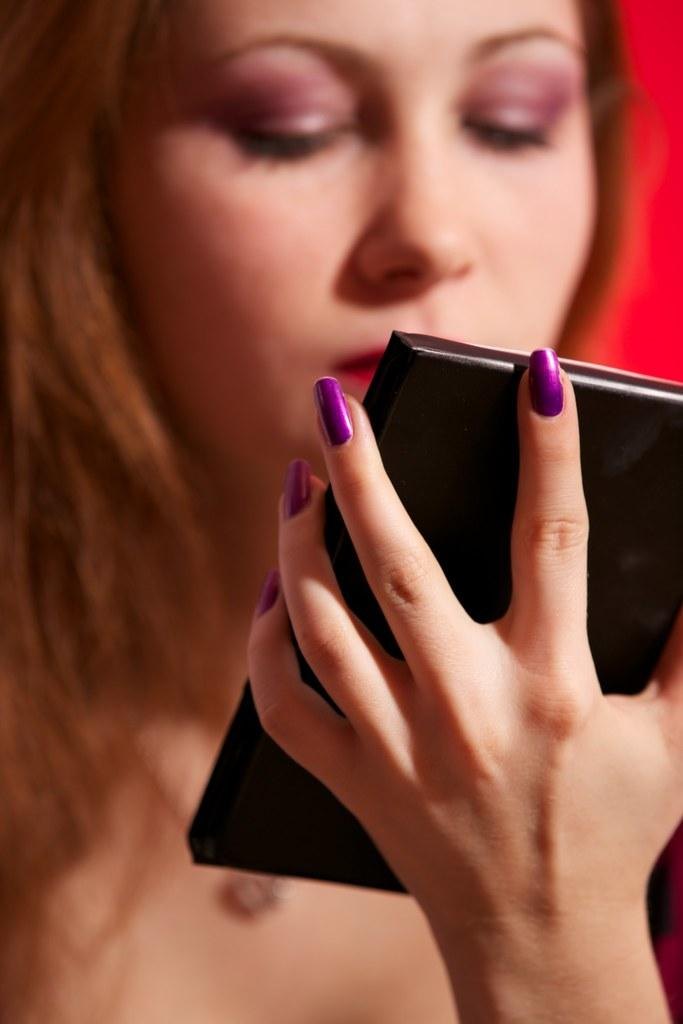Who is the main subject in the image? There is a woman in the image. What is the woman doing with her hand? The woman is holding an object with her hand. Can you describe the background of the image? The background of the image has a red color. Reasoning: Let'g: Let's think step by step in order to produce the conversation. We start by identifying the main subject in the image, which is the woman. Then, we describe what the woman is doing with her hand, which is holding an object. Finally, we focus on the background of the image, noting its red color. Absurd Question/Answer: What type of current can be seen flowing through the woman's body in the image? There is no current flowing through the woman's body in the image. How does the woman use magic to perform her task in the image? There is no indication of magic being used in the image; the woman is simply holding an object with her hand. What type of current can be seen flowing through the woman's body in the image? There is no current flowing through the woman's body in the image. How does the woman use magic to perform her task in the image? There is no indication of magic being used in the image; the woman is simply holding an object with her hand. 